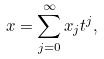Convert formula to latex. <formula><loc_0><loc_0><loc_500><loc_500>x = \sum _ { j = 0 } ^ { \infty } x _ { j } t ^ { j } ,</formula> 